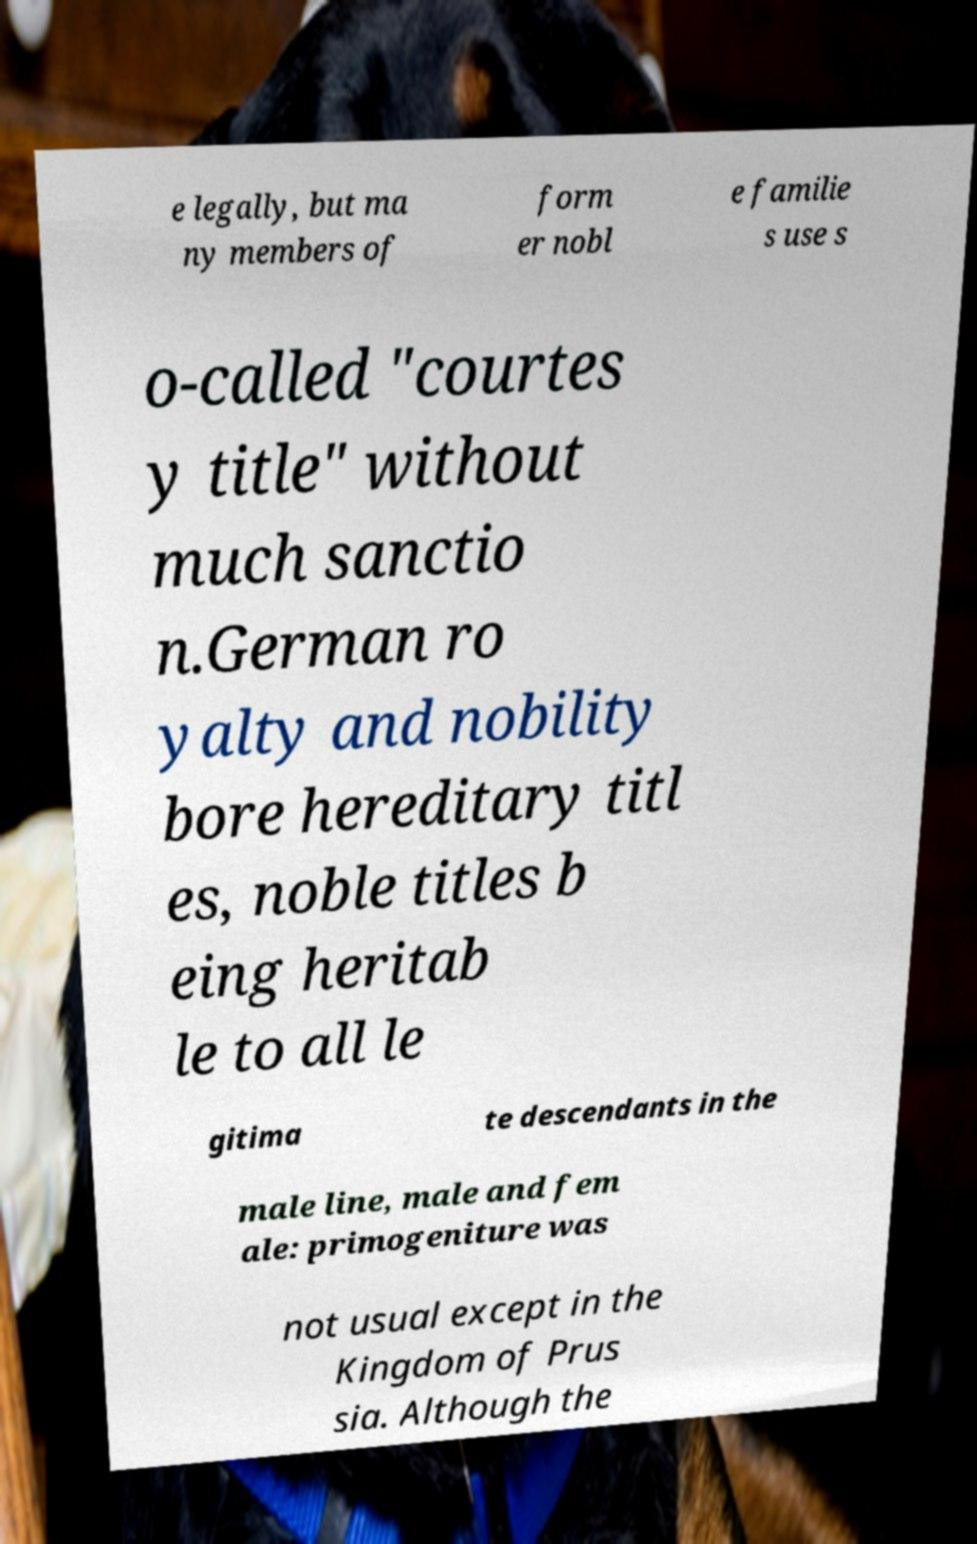Could you extract and type out the text from this image? e legally, but ma ny members of form er nobl e familie s use s o-called "courtes y title" without much sanctio n.German ro yalty and nobility bore hereditary titl es, noble titles b eing heritab le to all le gitima te descendants in the male line, male and fem ale: primogeniture was not usual except in the Kingdom of Prus sia. Although the 